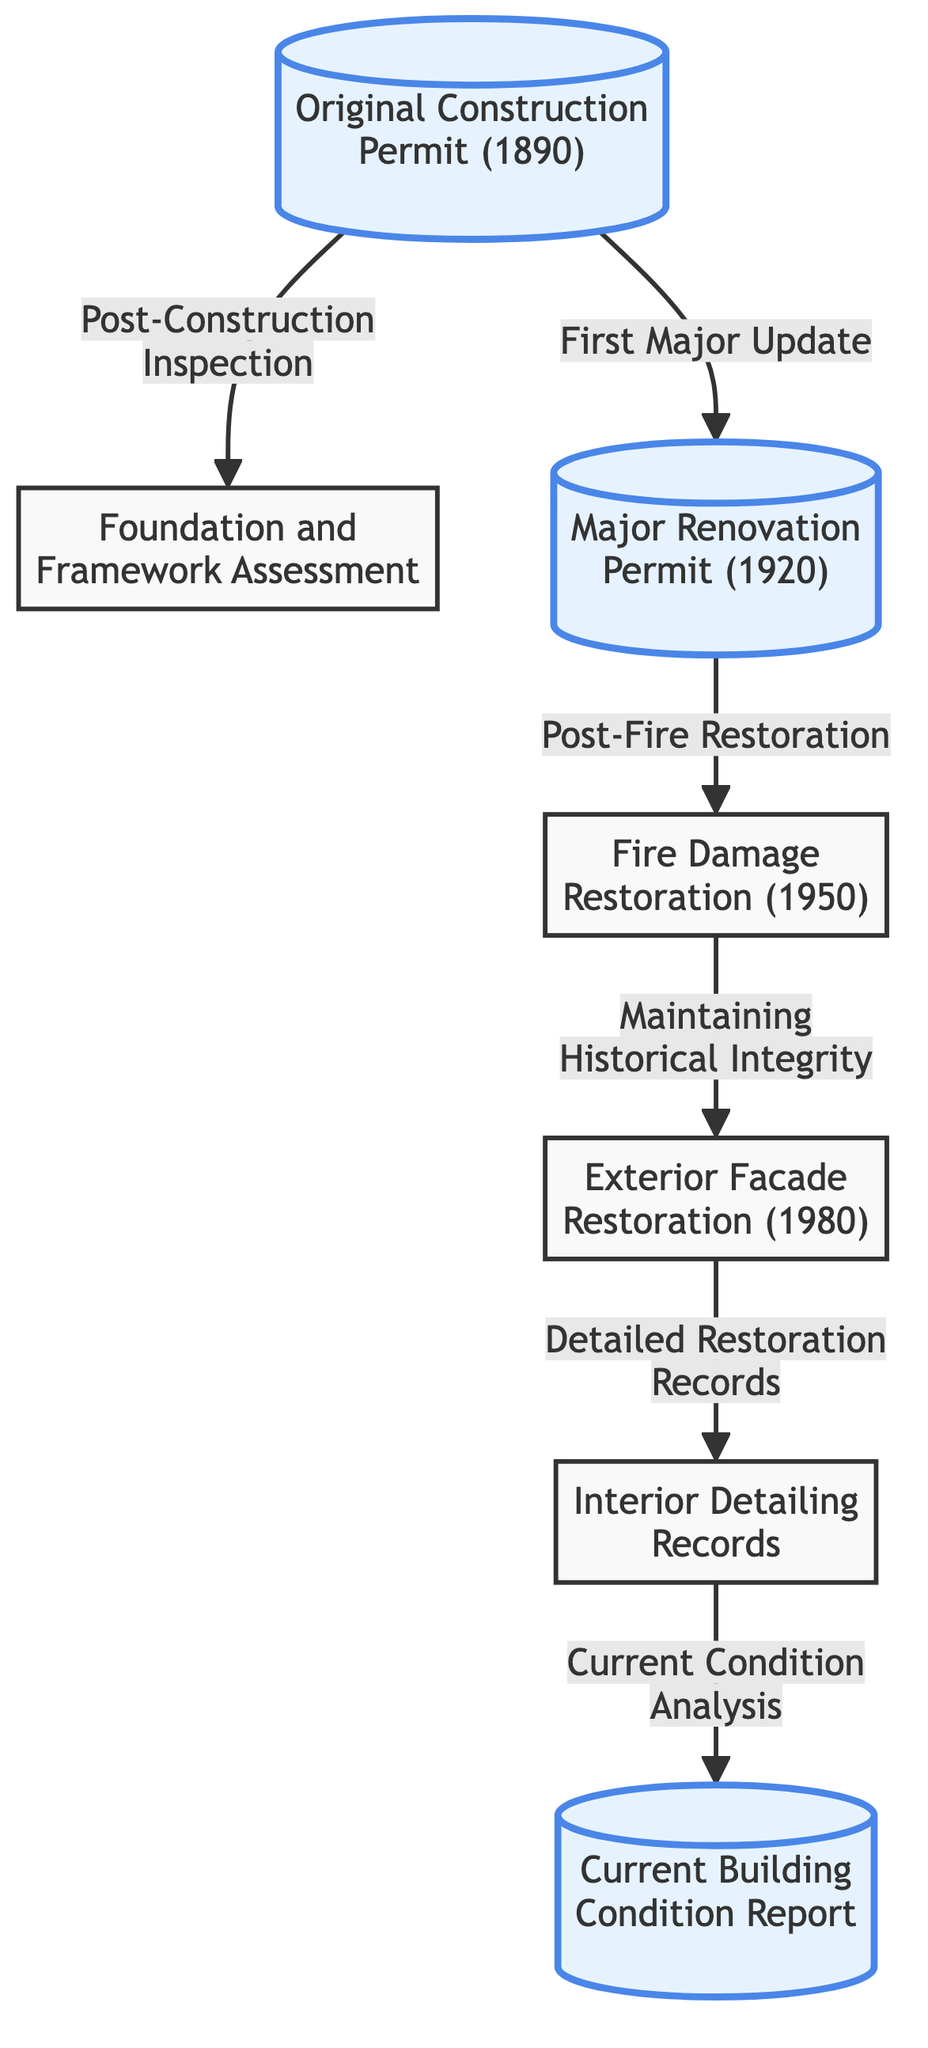What is the year of the original construction permit? The diagram specifies that the original construction permit was issued in the year 1890. This information is directly presented in the corresponding node.
Answer: 1890 What is the first major update after the original construction? According to the diagram, the first major update after the original construction was the major renovation permit, which occurred in 1920. This follows the original construction node in the flow.
Answer: Major Renovation Permit (1920) How many major restoration events are recorded in the diagram? The diagram includes four major restoration events: the original construction, the major renovation, the fire damage restoration, and the exterior facade restoration. This count can be derived from analyzing the nodes within the flowchart.
Answer: 4 What is the relationship between the fire damage restoration and the exterior facade restoration? The diagram indicates that the fire damage restoration leads to the exterior facade restoration, demonstrating a temporal and causal relationship where one event follows the other.
Answer: Leads to What is the most recent documentation assessed in the diagram? The most recent documentation listed in the diagram is the "Current Building Condition Report." This is at the end of the flow, indicating its most updated status.
Answer: Current Building Condition Report What type of assessment follows the original construction permit? The diagram shows that the assessment that follows the original construction permit is the foundation and framework assessment, indicating an evaluation of the initial structural elements.
Answer: Foundation and Framework Assessment What is the purpose of the detailed restoration records according to the diagram? The diagram connects the detailed restoration records to the maintenance of historical integrity, suggesting these records serve to ensure that restoration work is consistent with historical accuracy and quality.
Answer: Maintaining Historical Integrity Which restoration event is noted for its post-fire restoration activities? The diagram reflects that the fire damage restoration event, occurring in 1950, is specifically linked to post-fire restoration activities, emphasizing its focused purpose following the fire incident.
Answer: Fire Damage Restoration (1950) How does the current condition analysis relate to the rest of the diagram? The current condition analysis node is the last in the sequence, indicating an assessment that is derived from the detailed restoration records. It reflects the final step in analyzing the property’s overall state based on previous documentation.
Answer: Current Condition Analysis 